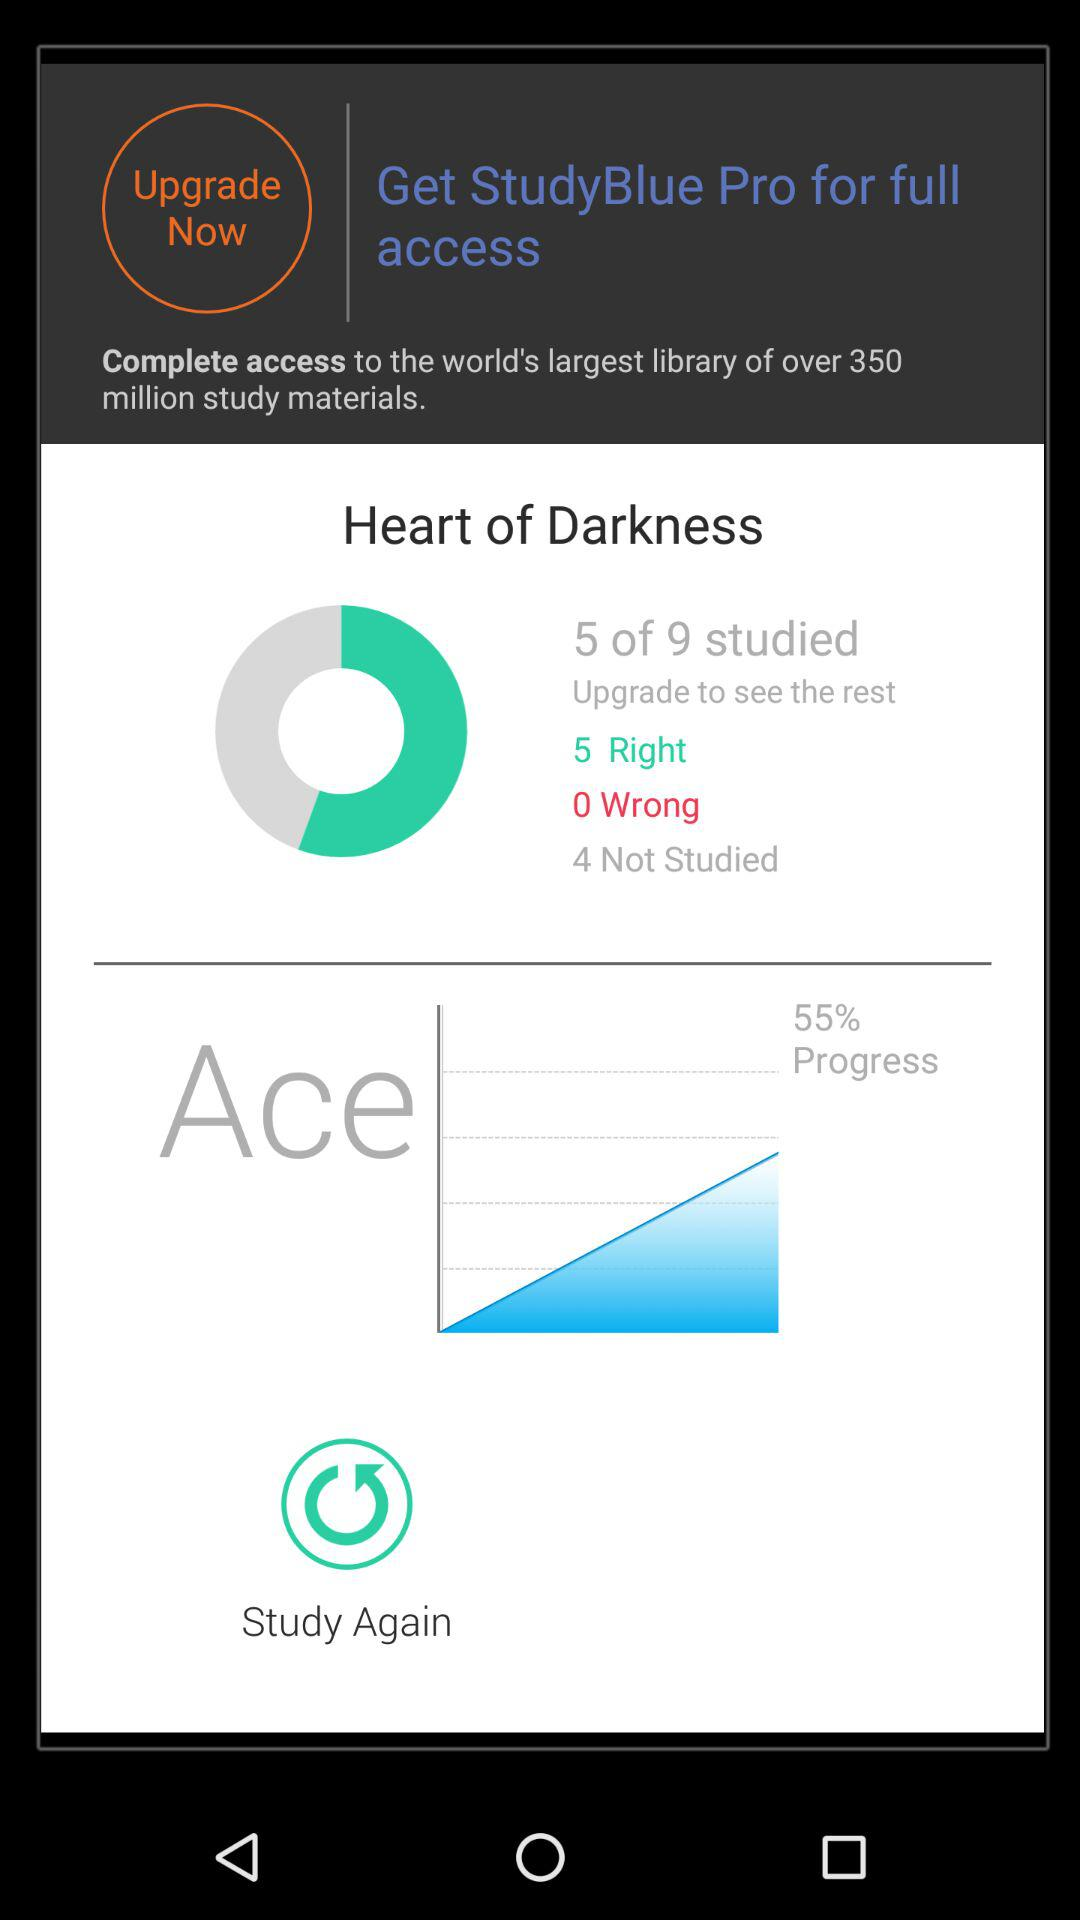What number is shown in the "Not Studied" option? The shown number is 4. 